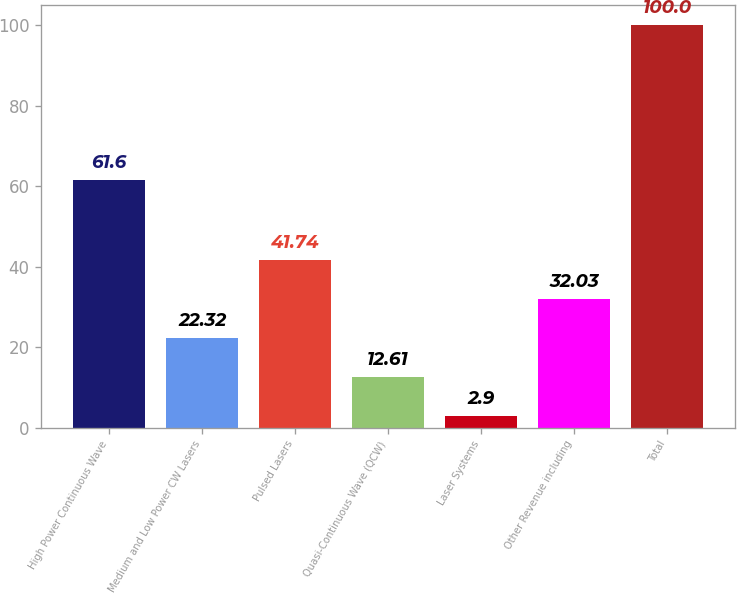<chart> <loc_0><loc_0><loc_500><loc_500><bar_chart><fcel>High Power Continuous Wave<fcel>Medium and Low Power CW Lasers<fcel>Pulsed Lasers<fcel>Quasi-Continuous Wave (QCW)<fcel>Laser Systems<fcel>Other Revenue including<fcel>Total<nl><fcel>61.6<fcel>22.32<fcel>41.74<fcel>12.61<fcel>2.9<fcel>32.03<fcel>100<nl></chart> 